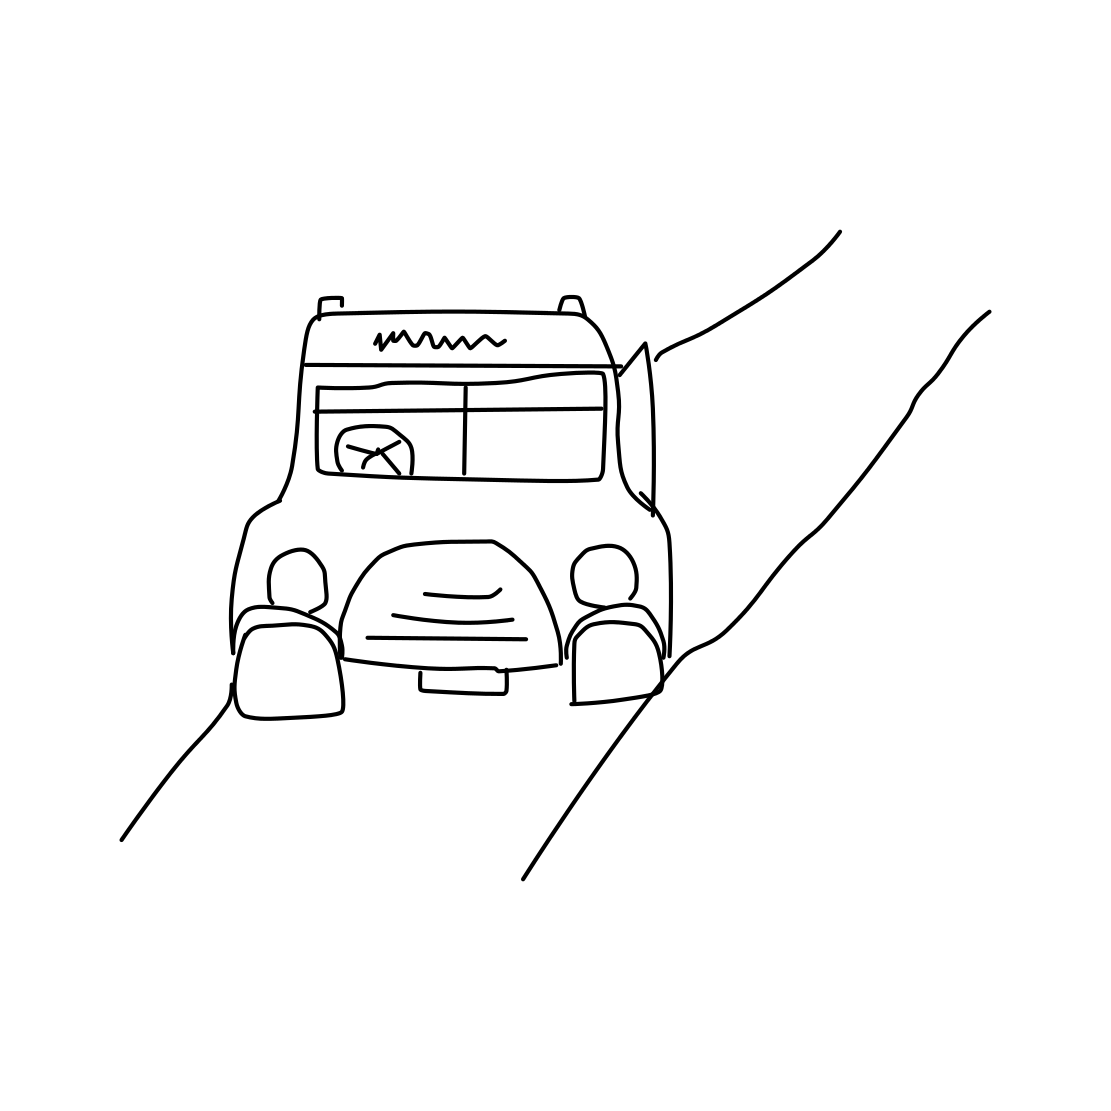The image seems to be a line drawing. What could be its potential use or purpose? The line drawing style of the image suggests it might be used for educational purposes, such as a coloring book for children or as a template for craft projects. It could also serve as a conceptual sketch in the initial stages of a product design or as part of a series of minimalist artwork. 